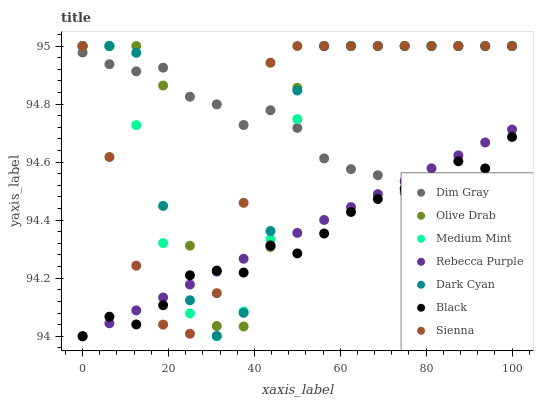Does Black have the minimum area under the curve?
Answer yes or no. Yes. Does Olive Drab have the maximum area under the curve?
Answer yes or no. Yes. Does Dim Gray have the minimum area under the curve?
Answer yes or no. No. Does Dim Gray have the maximum area under the curve?
Answer yes or no. No. Is Rebecca Purple the smoothest?
Answer yes or no. Yes. Is Olive Drab the roughest?
Answer yes or no. Yes. Is Dim Gray the smoothest?
Answer yes or no. No. Is Dim Gray the roughest?
Answer yes or no. No. Does Black have the lowest value?
Answer yes or no. Yes. Does Sienna have the lowest value?
Answer yes or no. No. Does Olive Drab have the highest value?
Answer yes or no. Yes. Does Dim Gray have the highest value?
Answer yes or no. No. Does Sienna intersect Medium Mint?
Answer yes or no. Yes. Is Sienna less than Medium Mint?
Answer yes or no. No. Is Sienna greater than Medium Mint?
Answer yes or no. No. 